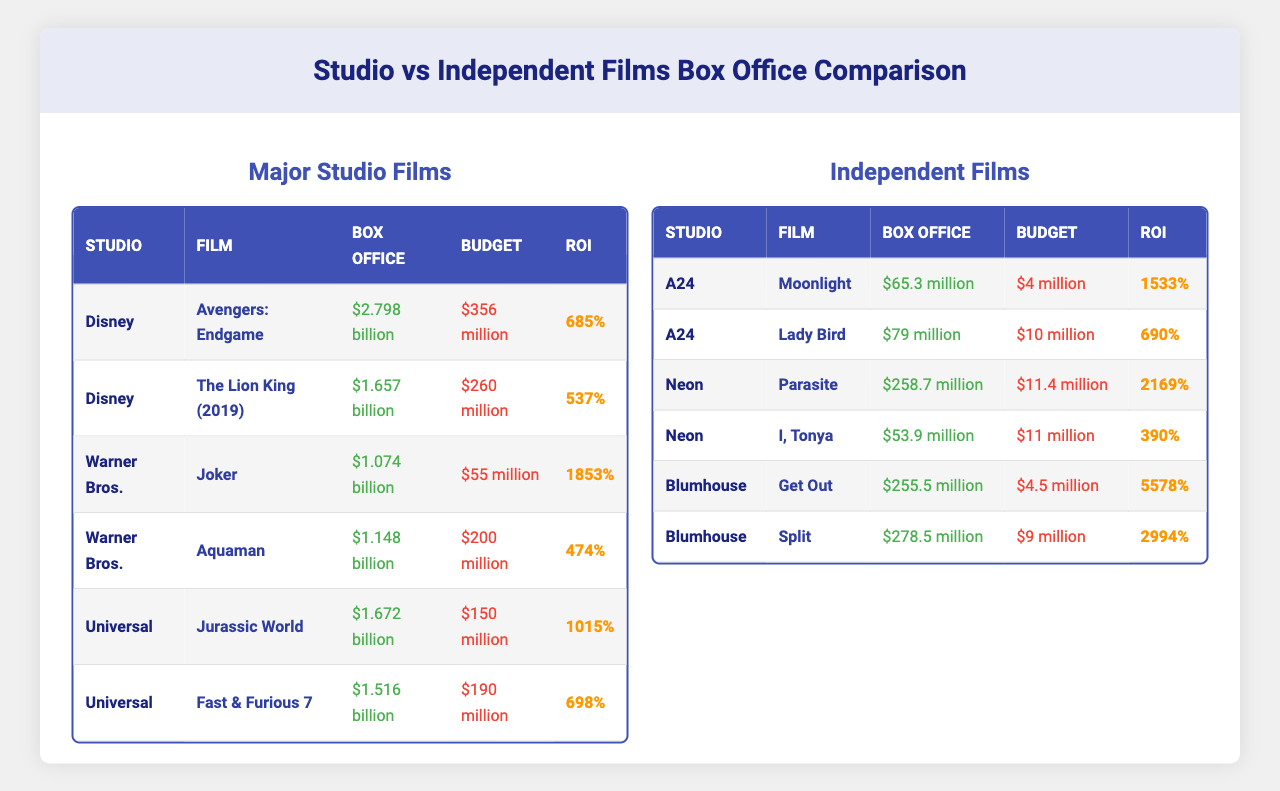What's the box office total for "Avengers: Endgame"? The table shows that the box office for "Avengers: Endgame" is reported as $2.798 billion.
Answer: $2.798 billion Which independent film has the highest return on investment (ROI)? In the independent films section, "Get Out" has the highest ROI of 5578%, according to the table.
Answer: "Get Out" What is the average box office for major studio films listed? To find the average, add the box office values: $2.798 billion + $1.657 billion + $1.074 billion + $1.148 billion + $1.672 billion + $1.516 billion = $9.865 billion. There are 6 films, so the average box office is $9.865 billion / 6 = approximately $1.644 billion.
Answer: Approximately $1.644 billion Is the ROI for "Parasite" greater than the ROI for "Joker"? The ROI for "Parasite" is 2169% and for "Joker" is 1853%. Since 2169% > 1853%, the statement is true.
Answer: Yes Which studio produced the film with the lowest budget? The film with the lowest budget is "Moonlight" with a budget of $4 million, produced by A24. Comparisons with others confirm it is the lowest.
Answer: A24 What is the total box office for all independent films listed? For total box office, add the following: $65.3 million + $79 million + $258.7 million + $53.9 million + $255.5 million + $278.5 million = $1.0149 billion. Thus, the total box office for all independent films is approximately $1.015 billion.
Answer: Approximately $1.015 billion Which major studio film has the highest ROI? "Joker" from Warner Bros. has the highest ROI at 1853% compared to other films listed in the major studio section.
Answer: "Joker" If we compare the average budget of major studio films and independent films, which one has the higher average? For major studio films, the budgets are $356 million, $260 million, $55 million, $200 million, $150 million, and $190 million, summing to $1.211 billion. The average is then $1.211 billion / 6 ≈ $201.833 million. For the independent films, budgets total $4 million + $10 million + $11.4 million + $11 million + $4.5 million + $9 million = $50.9 million. The average is $50.9 million / 6 ≈ $8.48 million. Thus, the average budget for major studio films is higher.
Answer: Major studio films How does the ROI of "Fast & Furious 7" compare to "Lady Bird"? The ROI for "Fast & Furious 7" is 698% while "Lady Bird" is 690%. Since 698% > 690%, "Fast & Furious 7" has a higher ROI.
Answer: "Fast & Furious 7" has a higher ROI Which independent film made over $250 million at the box office? "Get Out" and "Split" each made $255.5 million and $278.5 million respectively, as noted in the table. Hence, both made over $250 million.
Answer: "Get Out" and "Split" 